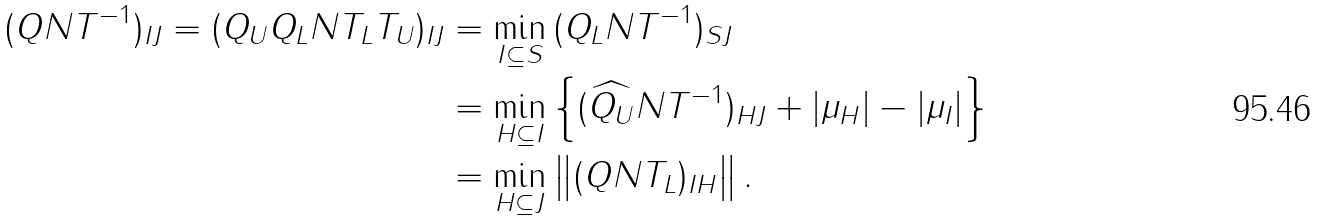Convert formula to latex. <formula><loc_0><loc_0><loc_500><loc_500>\| ( Q N T ^ { - 1 } ) _ { I J } \| = \| ( Q _ { U } Q _ { L } N T _ { L } T _ { U } ) _ { I J } \| & = \min _ { I \subseteq S } \| ( Q _ { L } N T ^ { - 1 } ) _ { S J } \| \\ & = \min _ { H \subseteq I } \left \{ \| ( \widehat { Q _ { U } } N T ^ { - 1 } ) _ { H J } \| + | \mu _ { H } | - | \mu _ { I } | \right \} \\ & = \min _ { H \subseteq J } \left \| ( Q N T _ { L } ) _ { I H } \right \| .</formula> 